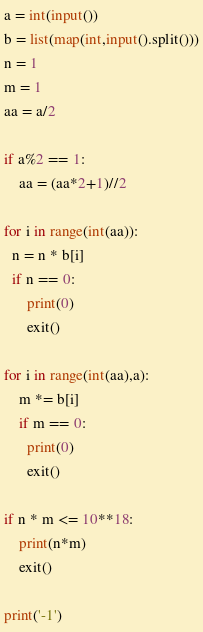Convert code to text. <code><loc_0><loc_0><loc_500><loc_500><_Python_>a = int(input())
b = list(map(int,input().split()))
n = 1
m = 1
aa = a/2

if a%2 == 1:
    aa = (aa*2+1)//2

for i in range(int(aa)):
  n = n * b[i]
  if n == 0:
      print(0)
      exit()
  
for i in range(int(aa),a):
    m *= b[i]
    if m == 0:
      print(0)
      exit()

if n * m <= 10**18:
    print(n*m)
    exit()
  
print('-1')</code> 